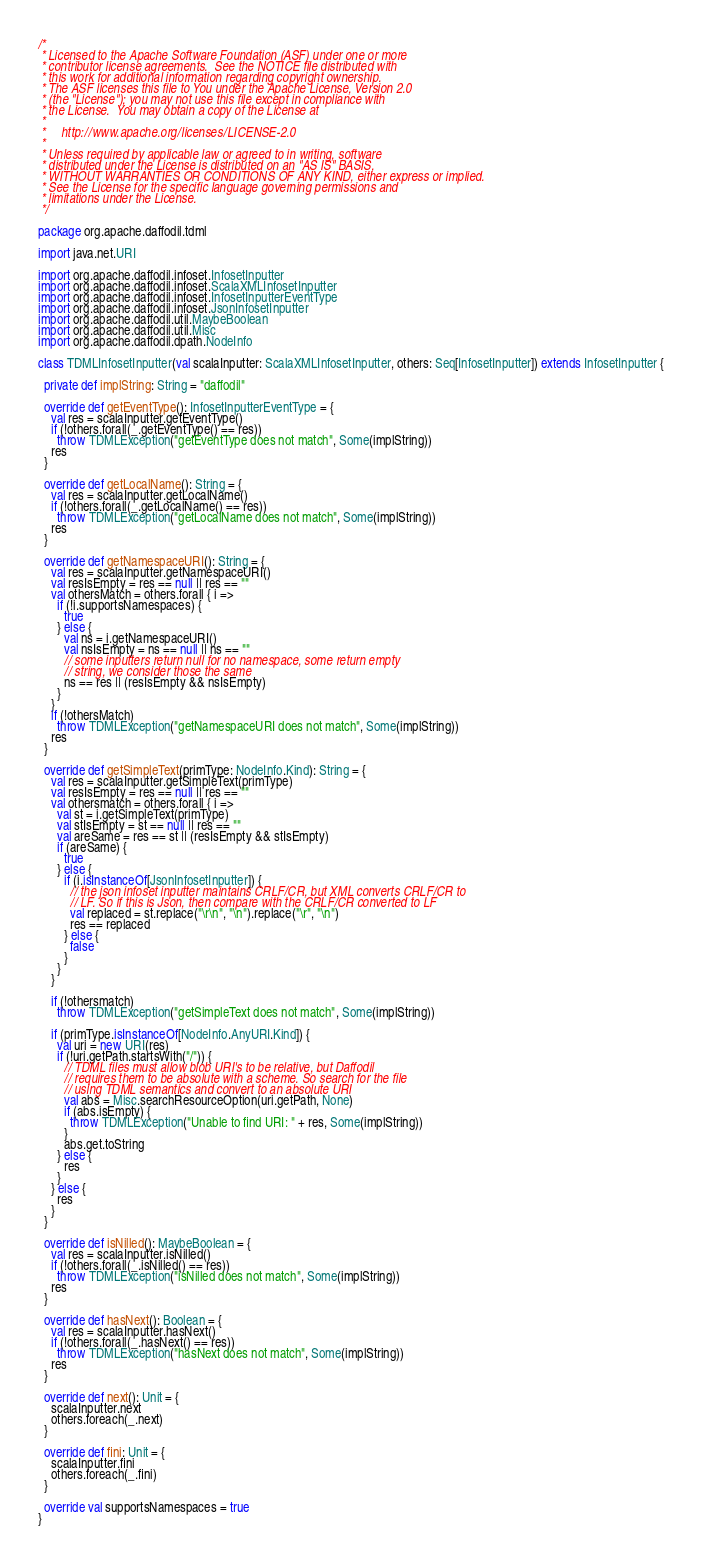Convert code to text. <code><loc_0><loc_0><loc_500><loc_500><_Scala_>/*
 * Licensed to the Apache Software Foundation (ASF) under one or more
 * contributor license agreements.  See the NOTICE file distributed with
 * this work for additional information regarding copyright ownership.
 * The ASF licenses this file to You under the Apache License, Version 2.0
 * (the "License"); you may not use this file except in compliance with
 * the License.  You may obtain a copy of the License at
 *
 *     http://www.apache.org/licenses/LICENSE-2.0
 *
 * Unless required by applicable law or agreed to in writing, software
 * distributed under the License is distributed on an "AS IS" BASIS,
 * WITHOUT WARRANTIES OR CONDITIONS OF ANY KIND, either express or implied.
 * See the License for the specific language governing permissions and
 * limitations under the License.
 */

package org.apache.daffodil.tdml

import java.net.URI

import org.apache.daffodil.infoset.InfosetInputter
import org.apache.daffodil.infoset.ScalaXMLInfosetInputter
import org.apache.daffodil.infoset.InfosetInputterEventType
import org.apache.daffodil.infoset.JsonInfosetInputter
import org.apache.daffodil.util.MaybeBoolean
import org.apache.daffodil.util.Misc
import org.apache.daffodil.dpath.NodeInfo

class TDMLInfosetInputter(val scalaInputter: ScalaXMLInfosetInputter, others: Seq[InfosetInputter]) extends InfosetInputter {

  private def implString: String = "daffodil"

  override def getEventType(): InfosetInputterEventType = {
    val res = scalaInputter.getEventType()
    if (!others.forall(_.getEventType() == res))
      throw TDMLException("getEventType does not match", Some(implString))
    res
  }

  override def getLocalName(): String = {
    val res = scalaInputter.getLocalName()
    if (!others.forall(_.getLocalName() == res))
      throw TDMLException("getLocalName does not match", Some(implString))
    res
  }

  override def getNamespaceURI(): String = {
    val res = scalaInputter.getNamespaceURI()
    val resIsEmpty = res == null || res == ""
    val othersMatch = others.forall { i =>
      if (!i.supportsNamespaces) {
        true
      } else {
        val ns = i.getNamespaceURI()
        val nsIsEmpty = ns == null || ns == ""
        // some inputters return null for no namespace, some return empty
        // string, we consider those the same
        ns == res || (resIsEmpty && nsIsEmpty)
      }
    }
    if (!othersMatch)
      throw TDMLException("getNamespaceURI does not match", Some(implString))
    res
  }

  override def getSimpleText(primType: NodeInfo.Kind): String = {
    val res = scalaInputter.getSimpleText(primType)
    val resIsEmpty = res == null || res == ""
    val othersmatch = others.forall { i =>
      val st = i.getSimpleText(primType)
      val stIsEmpty = st == null || res == ""
      val areSame = res == st || (resIsEmpty && stIsEmpty)
      if (areSame) {
        true
      } else {
        if (i.isInstanceOf[JsonInfosetInputter]) {
          // the json infoset inputter maintains CRLF/CR, but XML converts CRLF/CR to
          // LF. So if this is Json, then compare with the CRLF/CR converted to LF
          val replaced = st.replace("\r\n", "\n").replace("\r", "\n")
          res == replaced
        } else {
          false
        }
      }
    }

    if (!othersmatch)
      throw TDMLException("getSimpleText does not match", Some(implString))

    if (primType.isInstanceOf[NodeInfo.AnyURI.Kind]) {
      val uri = new URI(res)
      if (!uri.getPath.startsWith("/")) {
        // TDML files must allow blob URI's to be relative, but Daffodil
        // requires them to be absolute with a scheme. So search for the file
        // using TDML semantics and convert to an absolute URI
        val abs = Misc.searchResourceOption(uri.getPath, None)
        if (abs.isEmpty) {
          throw TDMLException("Unable to find URI: " + res, Some(implString))
        }
        abs.get.toString
      } else {
        res
      }
    } else {
      res
    }
  }

  override def isNilled(): MaybeBoolean = {
    val res = scalaInputter.isNilled()
    if (!others.forall(_.isNilled() == res))
      throw TDMLException("isNilled does not match", Some(implString))
    res
  }

  override def hasNext(): Boolean = {
    val res = scalaInputter.hasNext()
    if (!others.forall(_.hasNext() == res))
      throw TDMLException("hasNext does not match", Some(implString))
    res
  }

  override def next(): Unit = {
    scalaInputter.next
    others.foreach(_.next)
  }

  override def fini: Unit = {
    scalaInputter.fini
    others.foreach(_.fini)
  }

  override val supportsNamespaces = true
}
</code> 